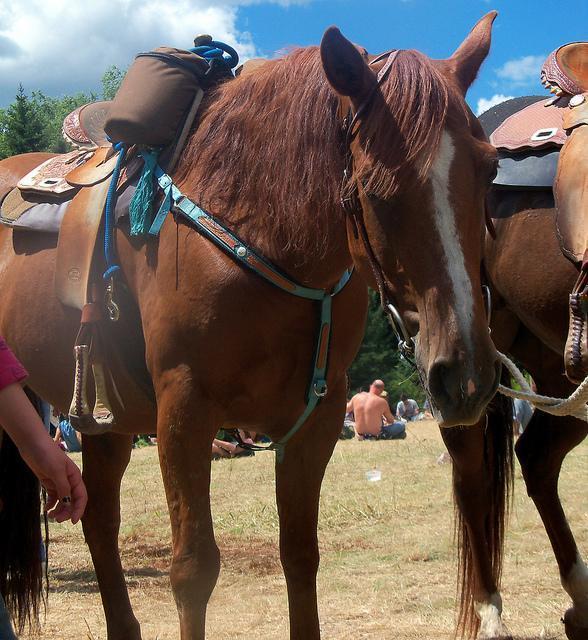How many horses are shown?
Give a very brief answer. 2. How many people are there?
Give a very brief answer. 2. How many horses are in the picture?
Give a very brief answer. 2. 